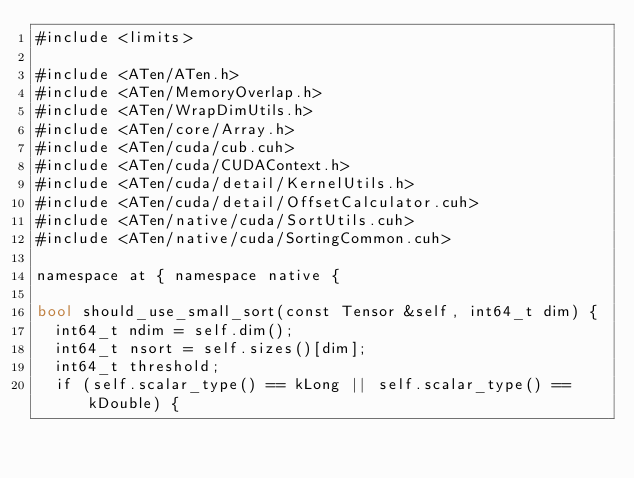<code> <loc_0><loc_0><loc_500><loc_500><_Cuda_>#include <limits>

#include <ATen/ATen.h>
#include <ATen/MemoryOverlap.h>
#include <ATen/WrapDimUtils.h>
#include <ATen/core/Array.h>
#include <ATen/cuda/cub.cuh>
#include <ATen/cuda/CUDAContext.h>
#include <ATen/cuda/detail/KernelUtils.h>
#include <ATen/cuda/detail/OffsetCalculator.cuh>
#include <ATen/native/cuda/SortUtils.cuh>
#include <ATen/native/cuda/SortingCommon.cuh>

namespace at { namespace native {

bool should_use_small_sort(const Tensor &self, int64_t dim) {
  int64_t ndim = self.dim();
  int64_t nsort = self.sizes()[dim];
  int64_t threshold;
  if (self.scalar_type() == kLong || self.scalar_type() == kDouble) {</code> 